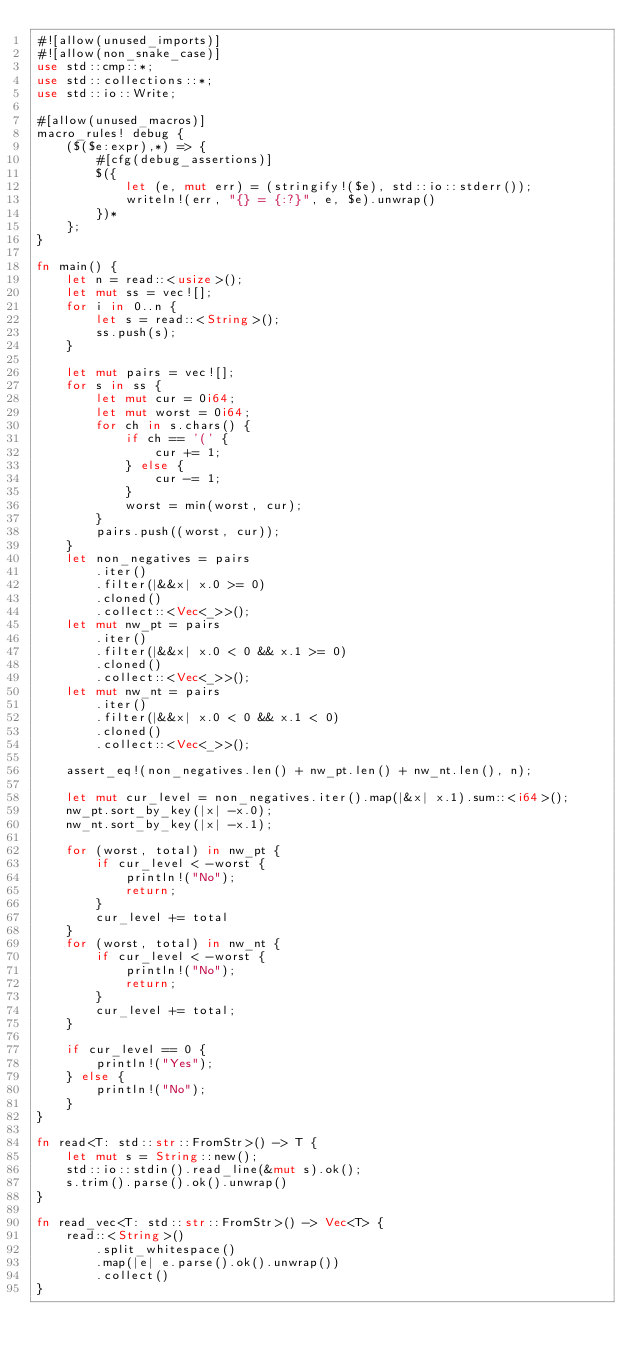Convert code to text. <code><loc_0><loc_0><loc_500><loc_500><_Rust_>#![allow(unused_imports)]
#![allow(non_snake_case)]
use std::cmp::*;
use std::collections::*;
use std::io::Write;

#[allow(unused_macros)]
macro_rules! debug {
    ($($e:expr),*) => {
        #[cfg(debug_assertions)]
        $({
            let (e, mut err) = (stringify!($e), std::io::stderr());
            writeln!(err, "{} = {:?}", e, $e).unwrap()
        })*
    };
}

fn main() {
    let n = read::<usize>();
    let mut ss = vec![];
    for i in 0..n {
        let s = read::<String>();
        ss.push(s);
    }

    let mut pairs = vec![];
    for s in ss {
        let mut cur = 0i64;
        let mut worst = 0i64;
        for ch in s.chars() {
            if ch == '(' {
                cur += 1;
            } else {
                cur -= 1;
            }
            worst = min(worst, cur);
        }
        pairs.push((worst, cur));
    }
    let non_negatives = pairs
        .iter()
        .filter(|&&x| x.0 >= 0)
        .cloned()
        .collect::<Vec<_>>();
    let mut nw_pt = pairs
        .iter()
        .filter(|&&x| x.0 < 0 && x.1 >= 0)
        .cloned()
        .collect::<Vec<_>>();
    let mut nw_nt = pairs
        .iter()
        .filter(|&&x| x.0 < 0 && x.1 < 0)
        .cloned()
        .collect::<Vec<_>>();

    assert_eq!(non_negatives.len() + nw_pt.len() + nw_nt.len(), n);

    let mut cur_level = non_negatives.iter().map(|&x| x.1).sum::<i64>();
    nw_pt.sort_by_key(|x| -x.0);
    nw_nt.sort_by_key(|x| -x.1);

    for (worst, total) in nw_pt {
        if cur_level < -worst {
            println!("No");
            return;
        }
        cur_level += total
    }
    for (worst, total) in nw_nt {
        if cur_level < -worst {
            println!("No");
            return;
        }
        cur_level += total;
    }

    if cur_level == 0 {
        println!("Yes");
    } else {
        println!("No");
    }
}

fn read<T: std::str::FromStr>() -> T {
    let mut s = String::new();
    std::io::stdin().read_line(&mut s).ok();
    s.trim().parse().ok().unwrap()
}

fn read_vec<T: std::str::FromStr>() -> Vec<T> {
    read::<String>()
        .split_whitespace()
        .map(|e| e.parse().ok().unwrap())
        .collect()
}
</code> 